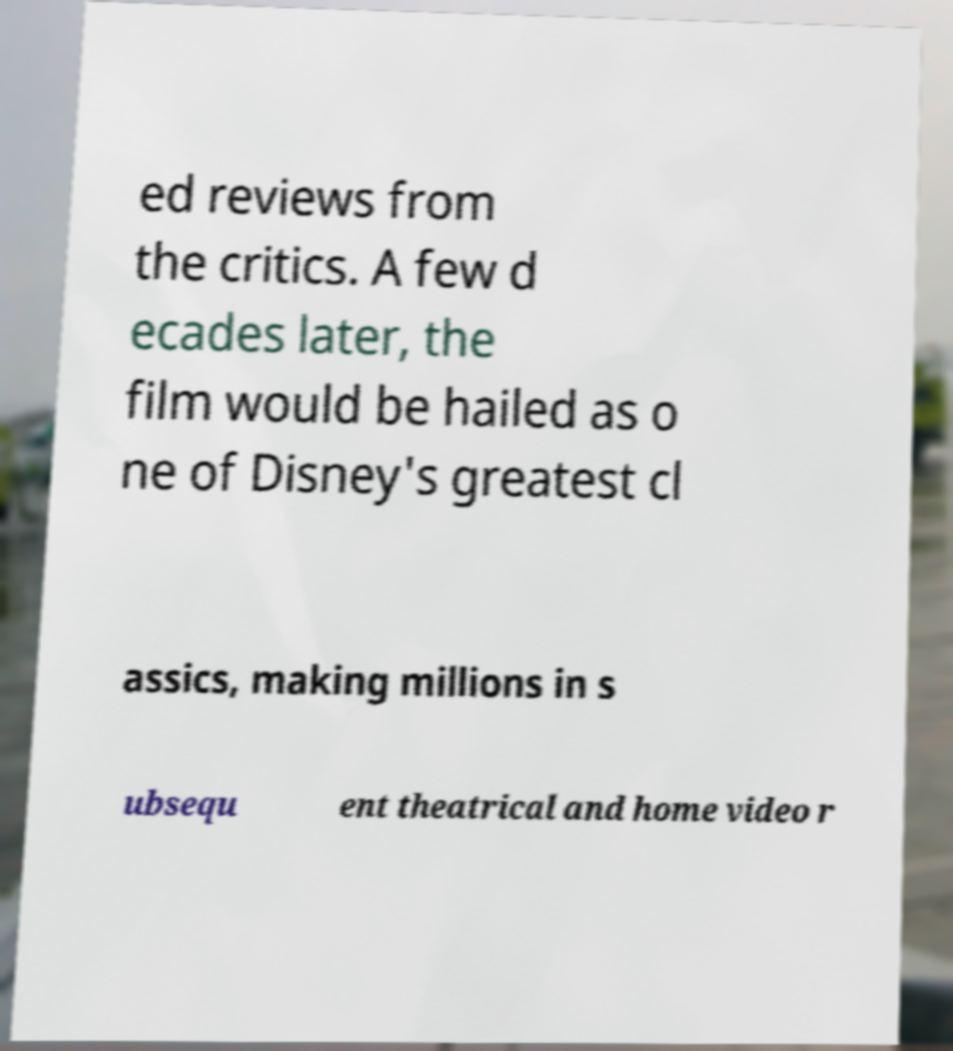Could you extract and type out the text from this image? ed reviews from the critics. A few d ecades later, the film would be hailed as o ne of Disney's greatest cl assics, making millions in s ubsequ ent theatrical and home video r 